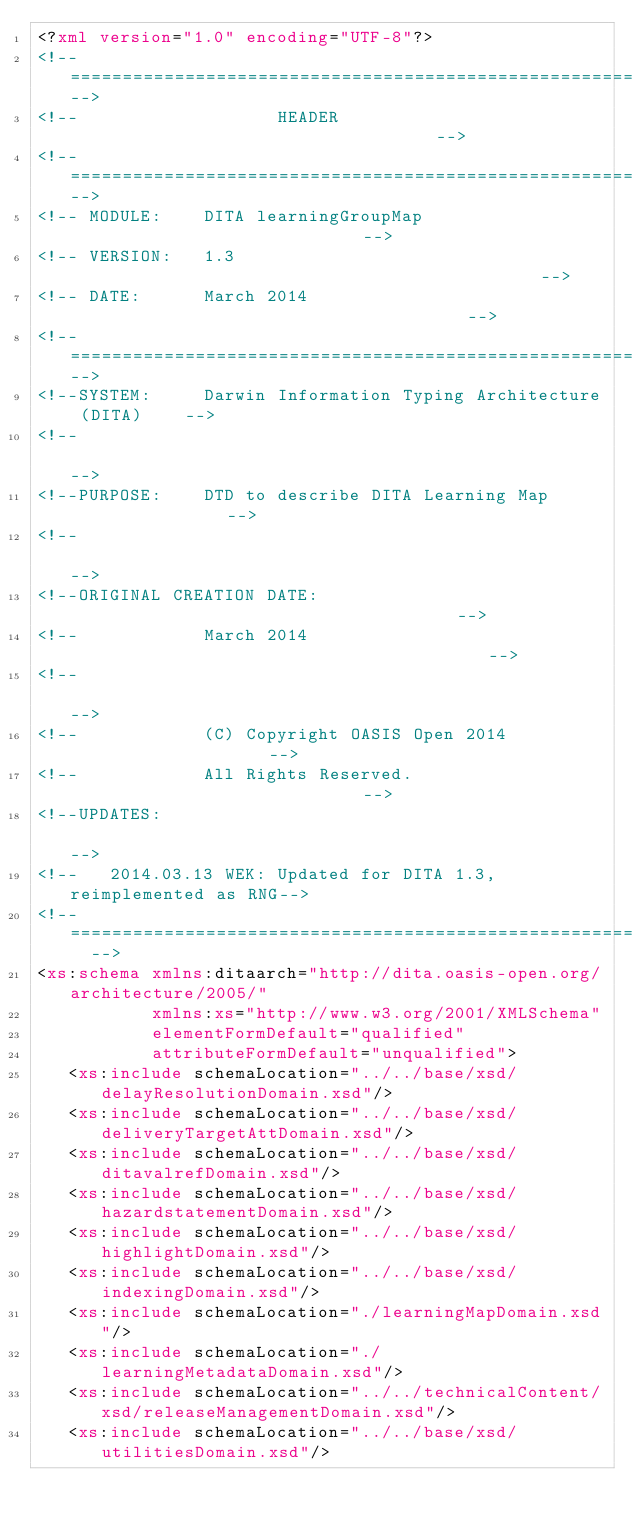Convert code to text. <code><loc_0><loc_0><loc_500><loc_500><_XML_><?xml version="1.0" encoding="UTF-8"?>
<!--=============================================================-->
<!--                   HEADER                                    -->
<!--=============================================================-->
<!-- MODULE:    DITA learningGroupMap                             -->
<!-- VERSION:   1.3                                              -->
<!-- DATE:      March 2014                                       -->
<!--=============================================================-->
<!--SYSTEM:     Darwin Information Typing Architecture (DITA)    -->
<!--                                                             -->
<!--PURPOSE:    DTD to describe DITA Learning Map                -->
<!--                                                             -->
<!--ORIGINAL CREATION DATE:                                      -->
<!--            March 2014                                         -->
<!--                                                             -->
<!--            (C) Copyright OASIS Open 2014                    -->
<!--            All Rights Reserved.                             -->
<!--UPDATES:                                                     -->
<!--   2014.03.13 WEK: Updated for DITA 1.3, reimplemented as RNG-->
<!--=============================================================  -->
<xs:schema xmlns:ditaarch="http://dita.oasis-open.org/architecture/2005/"
           xmlns:xs="http://www.w3.org/2001/XMLSchema"
           elementFormDefault="qualified"
           attributeFormDefault="unqualified">
   <xs:include schemaLocation="../../base/xsd/delayResolutionDomain.xsd"/>
   <xs:include schemaLocation="../../base/xsd/deliveryTargetAttDomain.xsd"/>
   <xs:include schemaLocation="../../base/xsd/ditavalrefDomain.xsd"/>
   <xs:include schemaLocation="../../base/xsd/hazardstatementDomain.xsd"/>
   <xs:include schemaLocation="../../base/xsd/highlightDomain.xsd"/>
   <xs:include schemaLocation="../../base/xsd/indexingDomain.xsd"/>
   <xs:include schemaLocation="./learningMapDomain.xsd"/>
   <xs:include schemaLocation="./learningMetadataDomain.xsd"/>
   <xs:include schemaLocation="../../technicalContent/xsd/releaseManagementDomain.xsd"/>
   <xs:include schemaLocation="../../base/xsd/utilitiesDomain.xsd"/>
</code> 